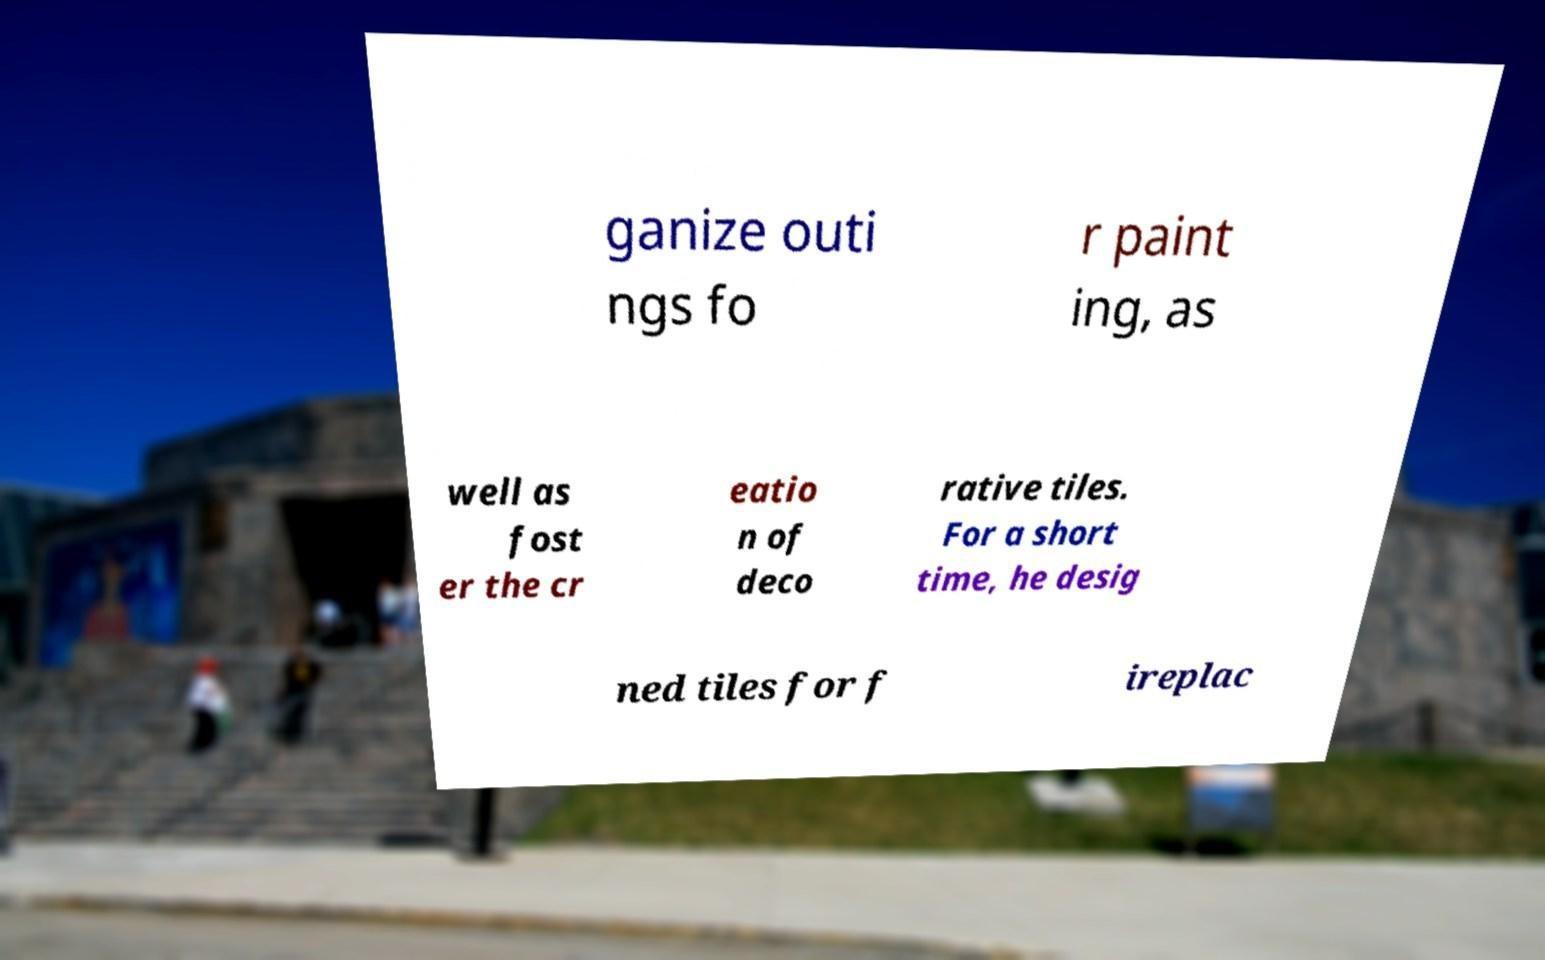Could you extract and type out the text from this image? ganize outi ngs fo r paint ing, as well as fost er the cr eatio n of deco rative tiles. For a short time, he desig ned tiles for f ireplac 